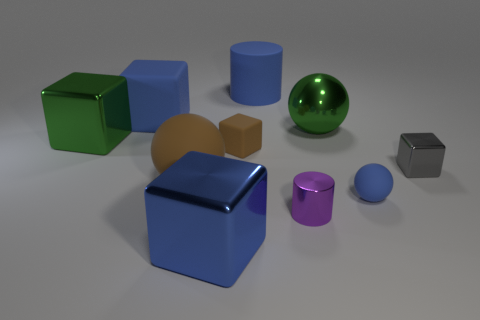Are there any objects that seem out of place or different from the others? Yes, the small gray cube stands out as it's the only object that has a distinctly different size in comparison to the other similarly shaped objects. 